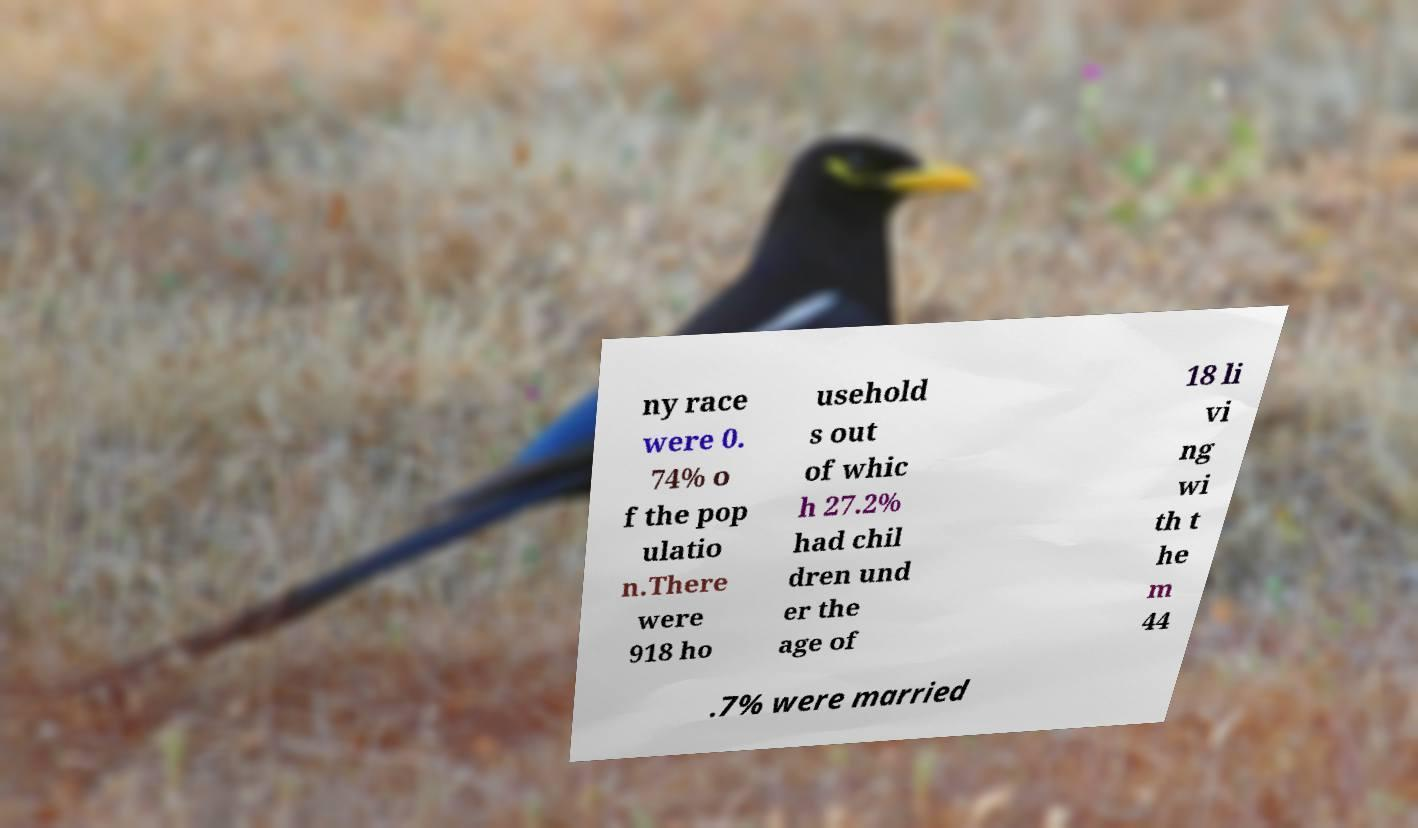Please read and relay the text visible in this image. What does it say? ny race were 0. 74% o f the pop ulatio n.There were 918 ho usehold s out of whic h 27.2% had chil dren und er the age of 18 li vi ng wi th t he m 44 .7% were married 